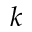<formula> <loc_0><loc_0><loc_500><loc_500>k</formula> 